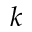<formula> <loc_0><loc_0><loc_500><loc_500>k</formula> 